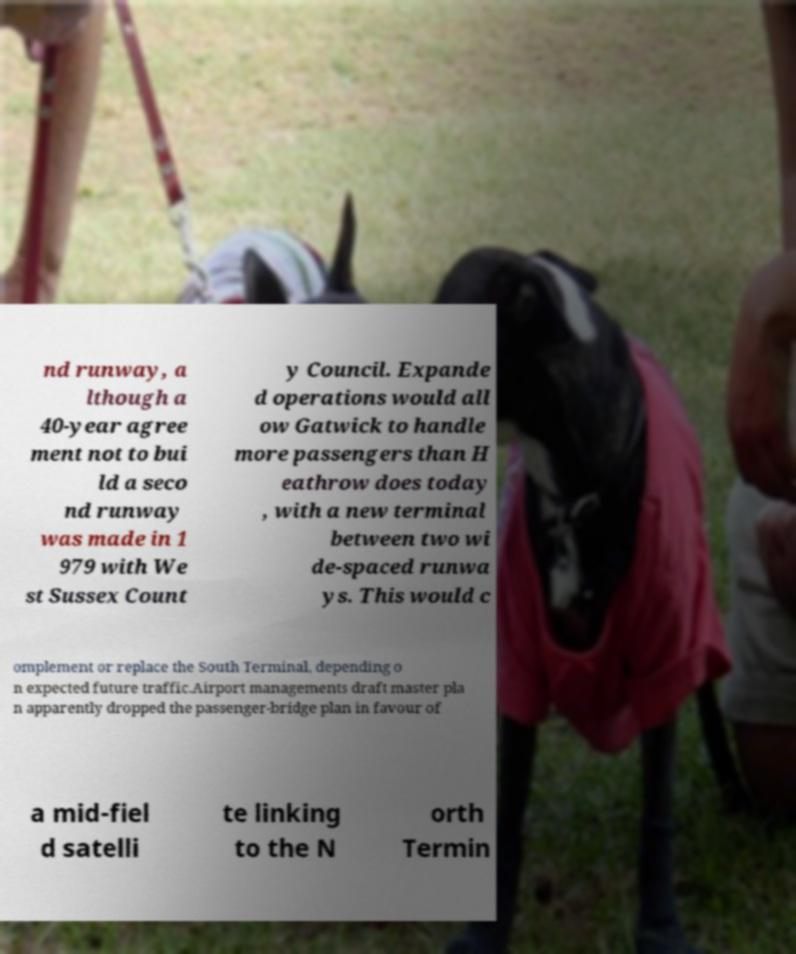Could you assist in decoding the text presented in this image and type it out clearly? nd runway, a lthough a 40-year agree ment not to bui ld a seco nd runway was made in 1 979 with We st Sussex Count y Council. Expande d operations would all ow Gatwick to handle more passengers than H eathrow does today , with a new terminal between two wi de-spaced runwa ys. This would c omplement or replace the South Terminal, depending o n expected future traffic.Airport managements draft master pla n apparently dropped the passenger-bridge plan in favour of a mid-fiel d satelli te linking to the N orth Termin 